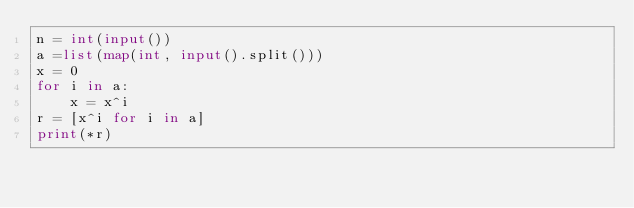Convert code to text. <code><loc_0><loc_0><loc_500><loc_500><_Python_>n = int(input())
a =list(map(int, input().split()))
x = 0
for i in a:
    x = x^i
r = [x^i for i in a]
print(*r)</code> 